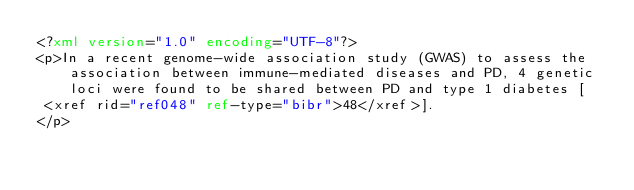<code> <loc_0><loc_0><loc_500><loc_500><_XML_><?xml version="1.0" encoding="UTF-8"?>
<p>In a recent genome-wide association study (GWAS) to assess the association between immune-mediated diseases and PD, 4 genetic loci were found to be shared between PD and type 1 diabetes [
 <xref rid="ref048" ref-type="bibr">48</xref>].
</p>
</code> 